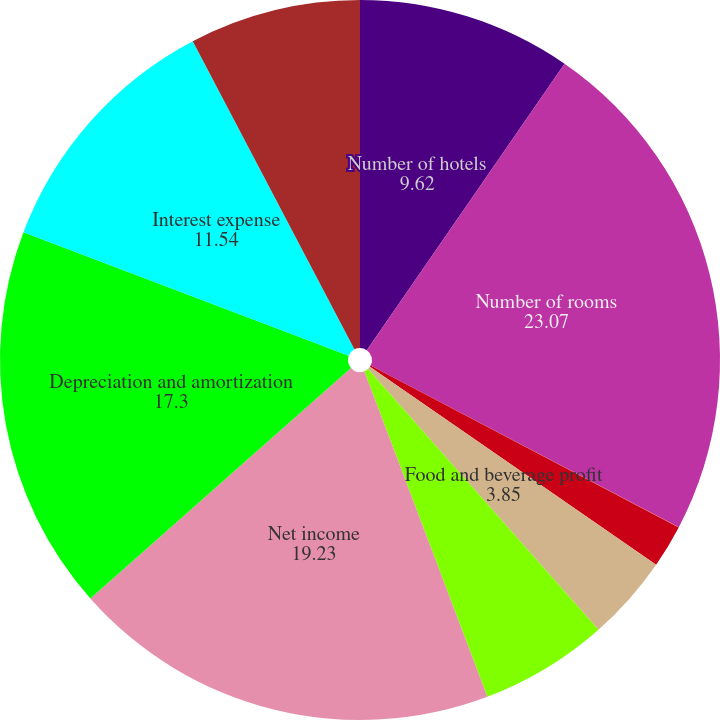<chart> <loc_0><loc_0><loc_500><loc_500><pie_chart><fcel>Number of hotels<fcel>Number of rooms<fcel>Operating profit margin (1)<fcel>Comparable hotel EBITDA margin<fcel>Food and beverage profit<fcel>Comparable hotel food and<fcel>Net income<fcel>Depreciation and amortization<fcel>Interest expense<fcel>Provision for income taxes<nl><fcel>9.62%<fcel>23.07%<fcel>0.01%<fcel>1.93%<fcel>3.85%<fcel>5.77%<fcel>19.23%<fcel>17.3%<fcel>11.54%<fcel>7.69%<nl></chart> 